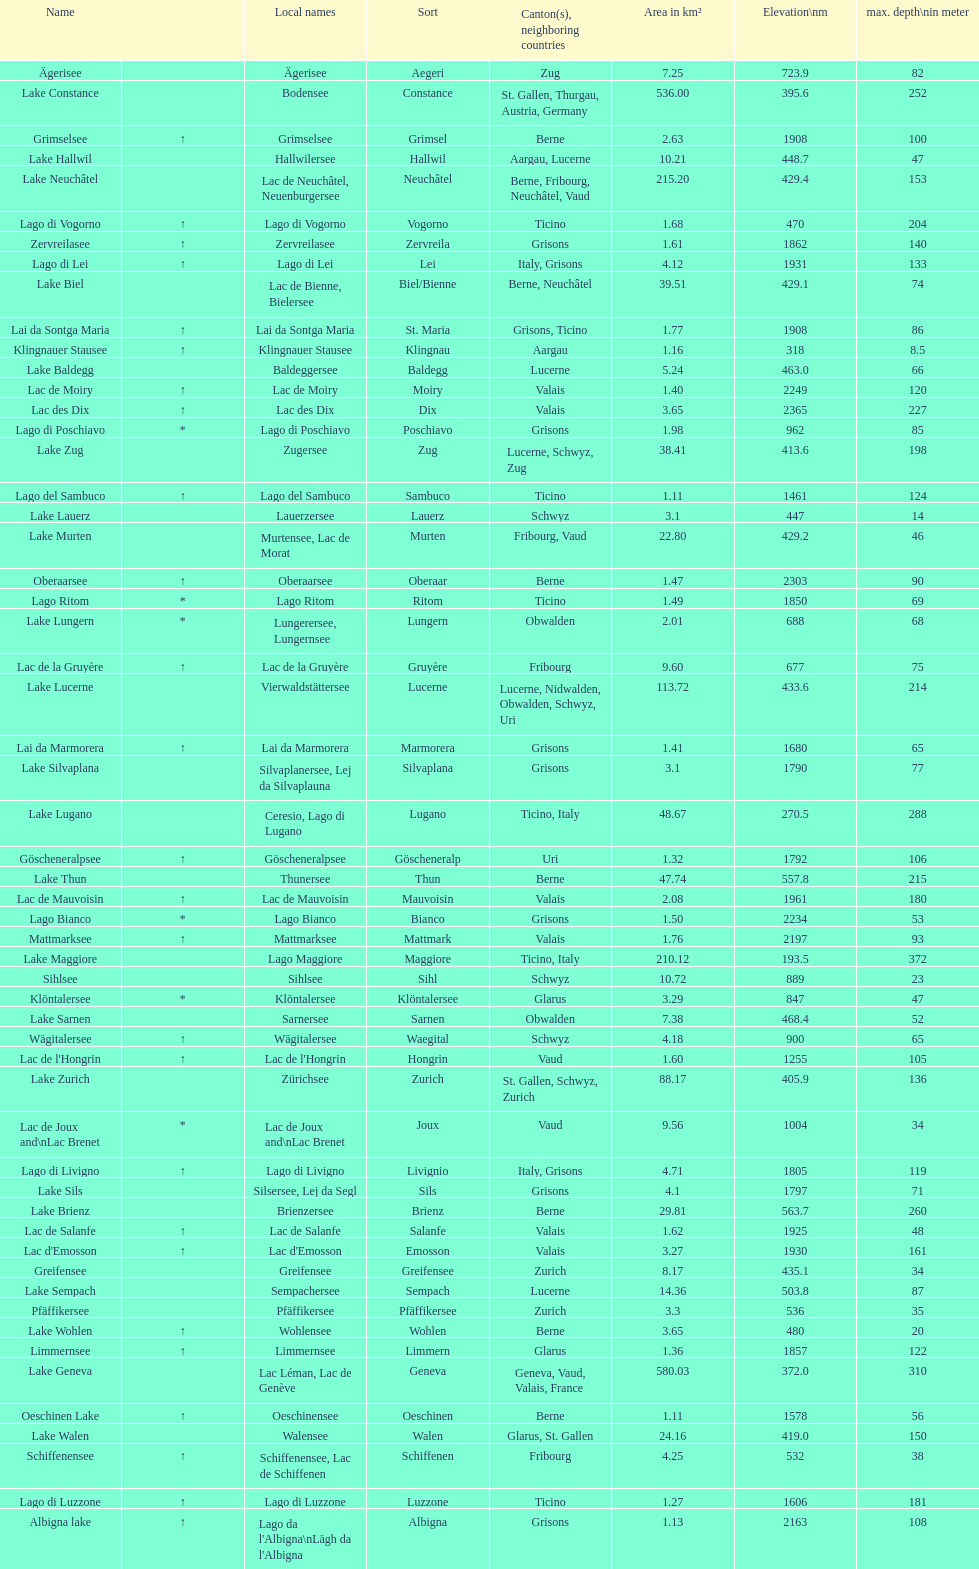Which lake has the deepest max depth? Lake Maggiore. 